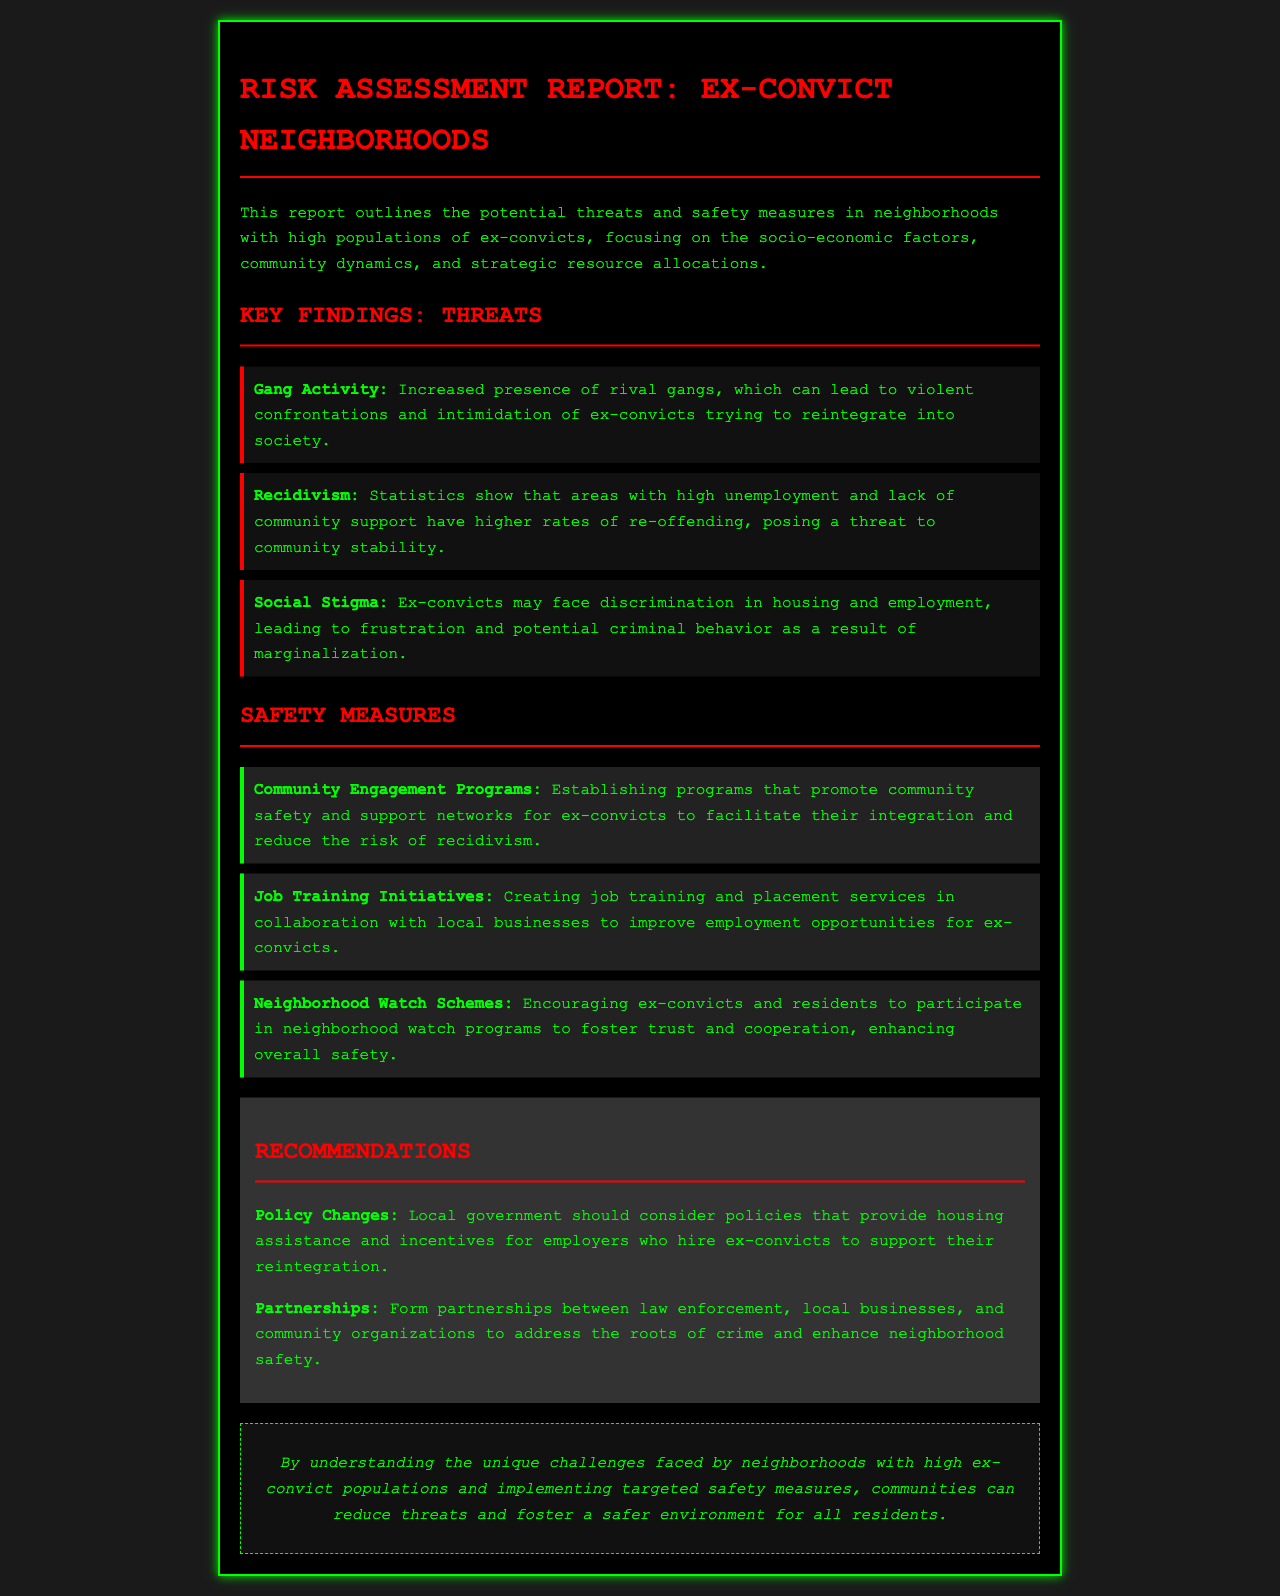What are the potential threats outlined in the report? The report lists specific threats in neighborhoods with high ex-convict populations, such as gang activity, recidivism, and social stigma.
Answer: gang activity, recidivism, social stigma What safety measure promotes community safety? The document specifies community engagement programs as a safety measure aimed at supporting ex-convicts and fostering safety in the community.
Answer: Community Engagement Programs What is the focus of job training initiatives mentioned in the report? It emphasizes creating job training and placement services to improve employment opportunities for ex-convicts.
Answer: employment opportunities How many key findings about threats are detailed in the report? The report mentions three key findings related to threats in neighborhoods with high ex-convict populations.
Answer: three What kind of partnerships does the report suggest forming? The report recommends forming partnerships between law enforcement, local businesses, and community organizations to enhance safety.
Answer: law enforcement, local businesses, community organizations What does the conclusion of the report emphasize? The conclusion highlights understanding the challenges faced by neighborhoods with high ex-convict populations and the implementation of targeted safety measures.
Answer: targeted safety measures What recommendation is made regarding housing? The local government is encouraged to consider policies that provide housing assistance for ex-convicts.
Answer: housing assistance Which threat is associated with higher rates of re-offending? The document states that recidivism is linked to areas with high unemployment and lack of community support.
Answer: recidivism 